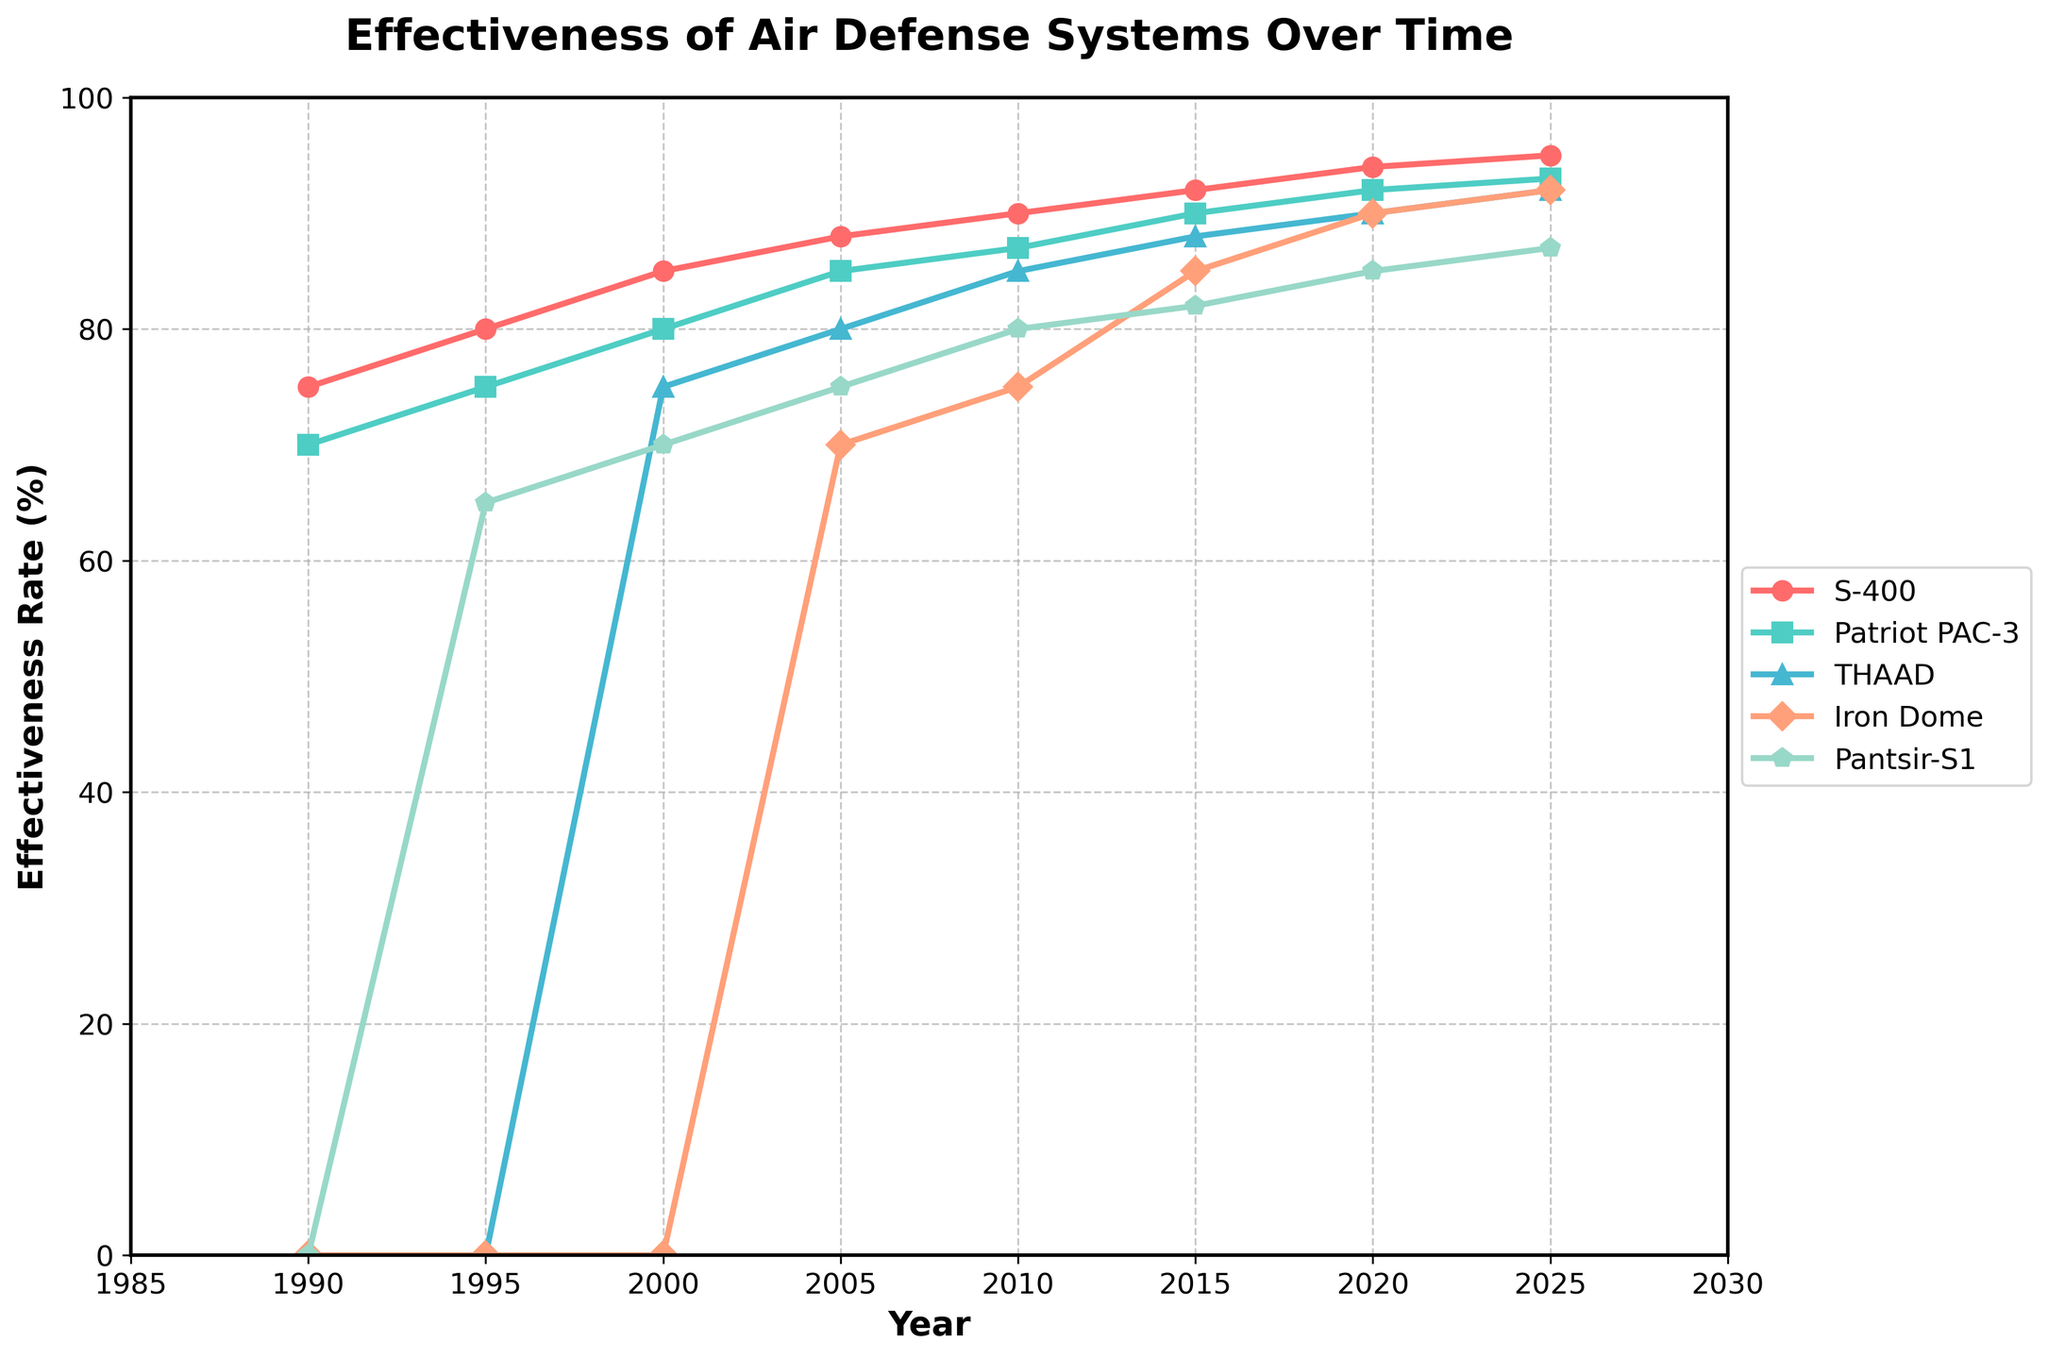Which air defense system shows the highest effectiveness rate in 2025? Looking at the year 2025 on the x-axis, observe the y-axis values for each defense system. The S-400 and Patriot PAC-3 both have high rates, but the S-400 has the highest at 95%.
Answer: S-400 How did the effectiveness of the Iron Dome change between 2005 and 2015? Find the y-axis values for the Iron Dome in 2005 and 2015. The effectiveness in 2005 is 70%, and it increases to 85% by 2015, a change of 15%.
Answer: Increased by 15% Which air defense system has the steepest increase in effectiveness rate from 1990 to 2000? Compare the slopes of the lines between these years for each system. The THAAD system shows a steep increase from 0% in 1990 to 75% in 2000.
Answer: THAAD By how much did the effectiveness rate of Patriot PAC-3 change from 1990 to 2020? The Patriot PAC-3 starts at 70% in 1990 and rises to 92% in 2020. The change is 92% - 70% = 22%.
Answer: 22% Which system had a higher effectiveness rate in 2010: Patriot PAC-3 or Iron Dome? Check the y-axis values for both systems in 2010. Patriot PAC-3 is at 87%, and Iron Dome is at 75%.
Answer: Patriot PAC-3 What is the average effectiveness rate of the Pantsir-S1 between 1995 and 2025? Find and sum the effectiveness rates for Pantsir-S1 at 1995 (65%), 2000 (70%), 2005 (75%), 2010 (80%), 2015 (82%), 2020 (85%), and 2025 (87%). The sum is 544. Divide by the number of data points (7).
Answer: Approx. 77.71% Which year did the S-400 reach an effectiveness rate of 88%? Follow the S-400 line until it intersects the 88% mark on the y-axis, which happens in the year 2005.
Answer: 2005 Compare the effectiveness rates of THAAD and Iron Dome in 2015, which system is more effective? For the year 2015, THAAD has an effectiveness rate of 88% and Iron Dome has 85%. THAAD is more effective.
Answer: THAAD Which defense system had the lowest effectiveness rate in 2000, and what was it? Check the y-axis values for all systems in 2000. The Iron Dome is at 0%, making it the lowest.
Answer: Iron Dome, 0% Based on the figure, which air defense system had a consistent increase in effectiveness from 1990 to 2025? All systems show an increase, but the S-400 shows a consistent and smooth upward trend throughout the period without dips.
Answer: S-400 